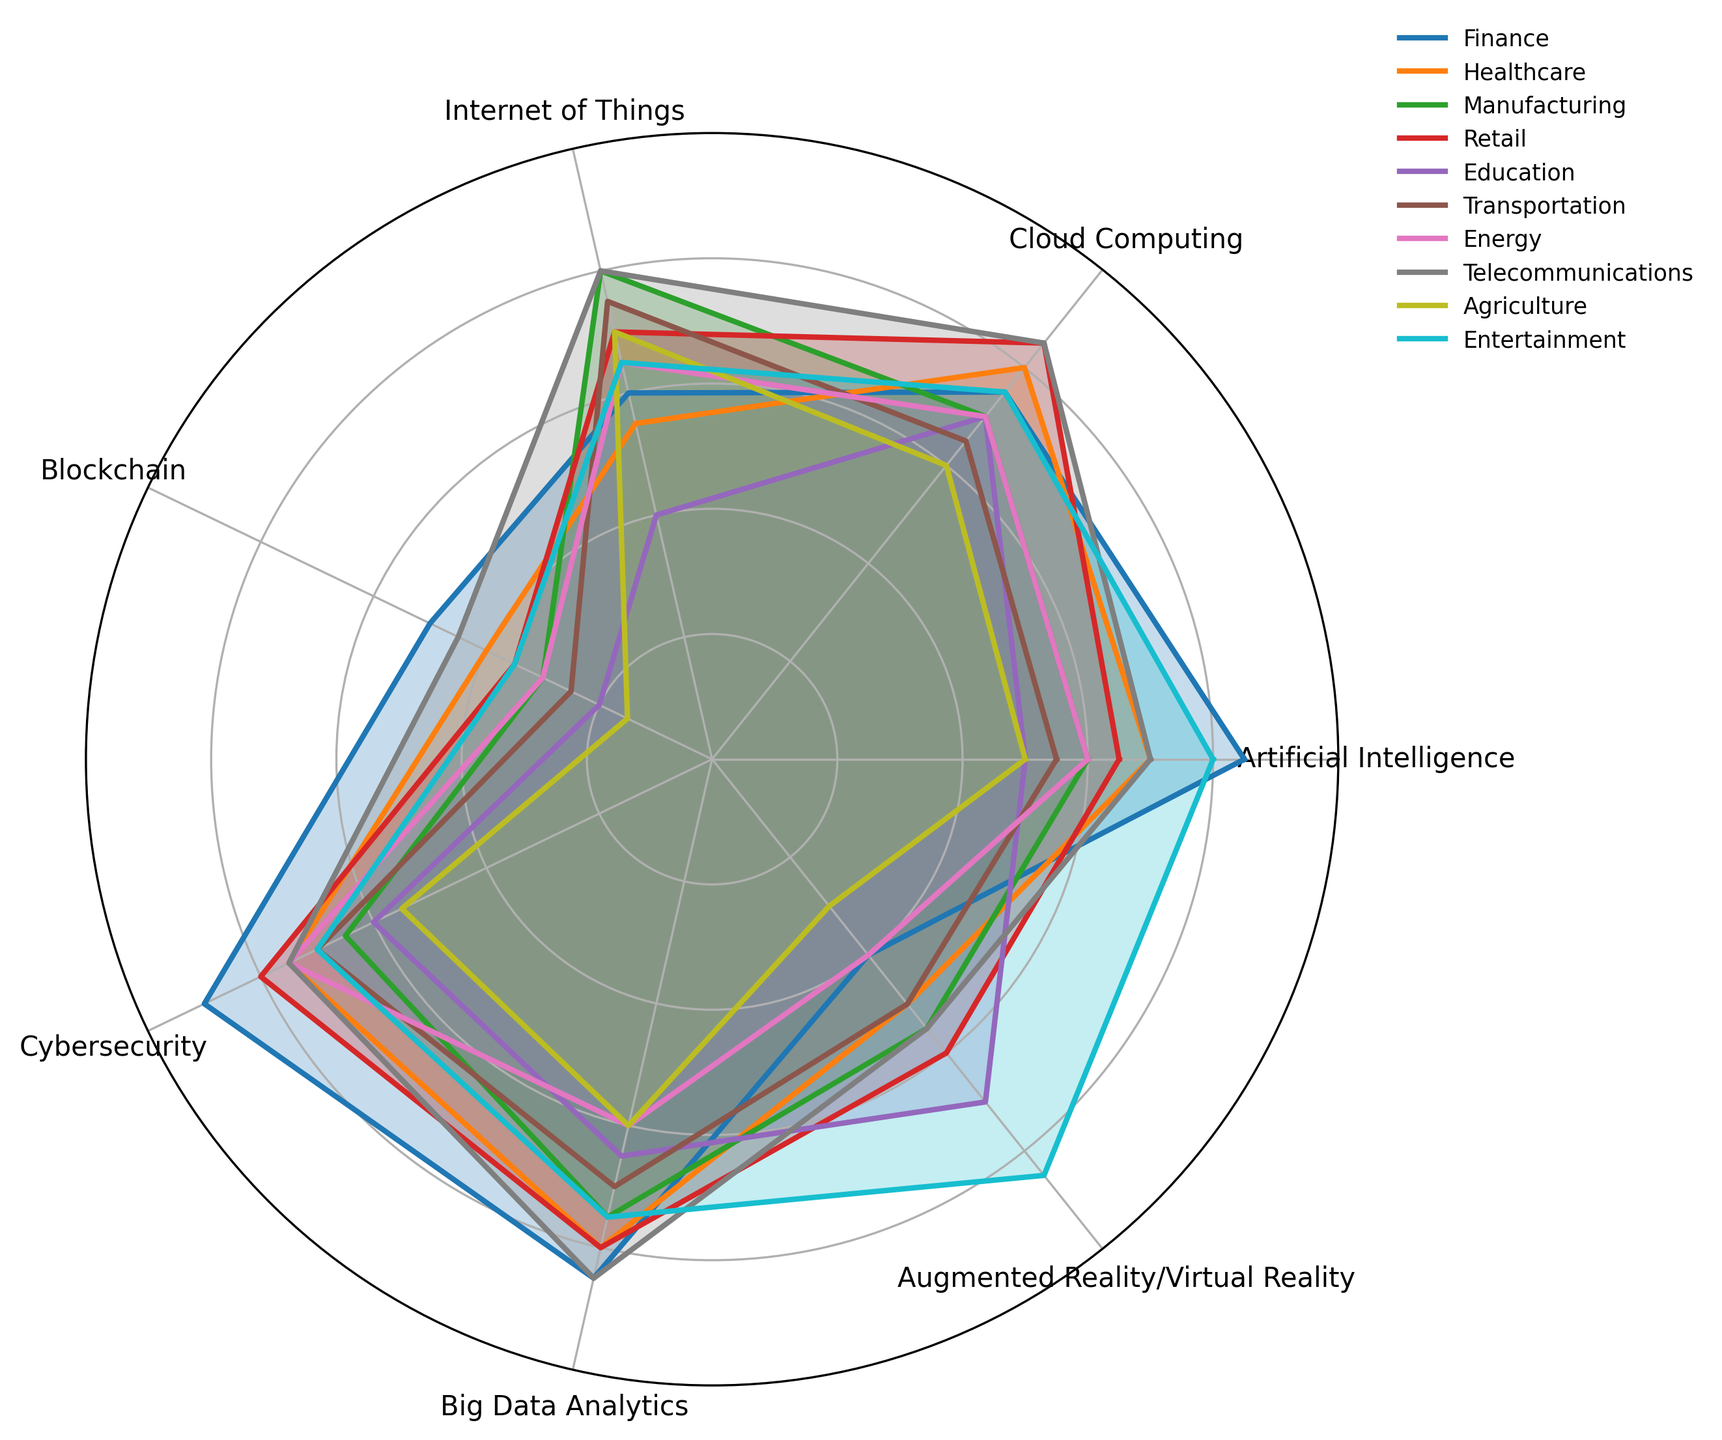What industry has the highest adoption rate of Artificial Intelligence (AI)? Finance shows the highest adoption rate for AI at 85%, as depicted by the longest radius in the AI sector of the radar chart.
Answer: Finance Which technology type does the Education industry adopt the most? The longest segment for the Education industry points towards AR/VR, with a value of 70%.
Answer: AR/VR What is the average adoption rate of Blockchain technology across all industries? Summing all Blockchain adoption rates (50+40+30+35+20+25+30+45+15+35 = 325) and dividing by the number of industries (10), the average is 325/10 = 32.5.
Answer: 32.5 Is the adoption rate of Cybersecurity in Manufacturing higher or lower than in Healthcare? By comparing the lengths, Manufacturing shows 65%, whereas Healthcare shows 75%. Thus, Healthcare's adoption rate is higher.
Answer: Lower Which two industries have equal adoption rates for Big Data Analytics? Both Finance and Telecommunications display identical radii for Big Data Analytics at 85%.
Answer: Finance and Telecommunications What is the median adoption rate of Internet of Things (IoT) technologies across all industries? The sorted IoT adoption rates are [40, 55, 60, 65, 70, 70, 75, 80, 80, 80]. With 10 data points, the median is the average of the 5th and 6th values (70+70)/2 = 70.
Answer: 70 Compare the adoption rates of Cloud Computing between Retail and Finance industries. Which is higher? The segment representing Retail in Cloud Computing reaches 85%, while Finance shows 75%. Hence, Retail's adoption rate is higher.
Answer: Retail By how much does the adoption rate of AR/VR in Entertainment exceed that in Finance? Entertainment shows 85% for AR/VR, while Finance shows 40%. The difference is 85 - 40 = 45%.
Answer: 45 In which technology type is Energy's adoption rate the lowest, and what is its value? Energy's shortest radius in the radar chart occurs at AR/VR, with a value of 40%.
Answer: AR/VR, 40 